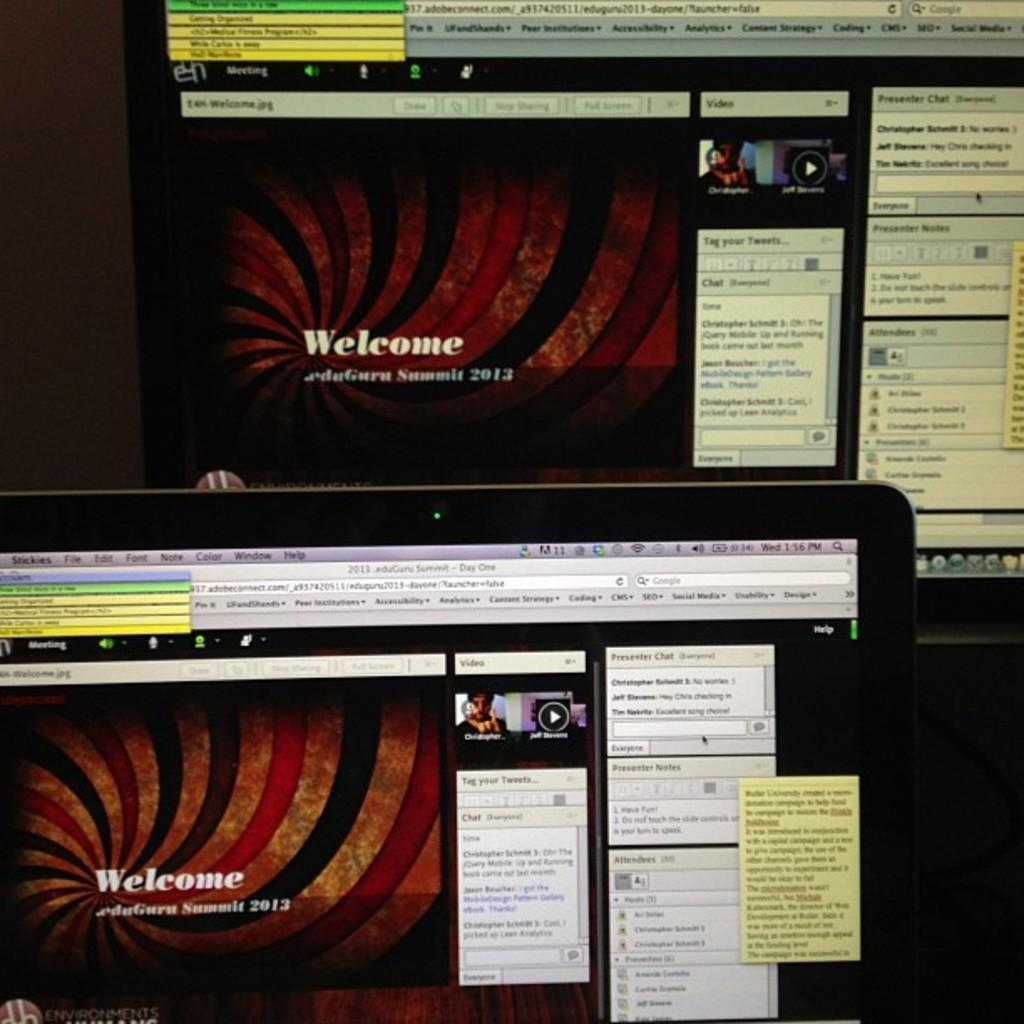<image>
Present a compact description of the photo's key features. Monitors with Welcome eduGuru Summit 2013 messages on them are displayed. 